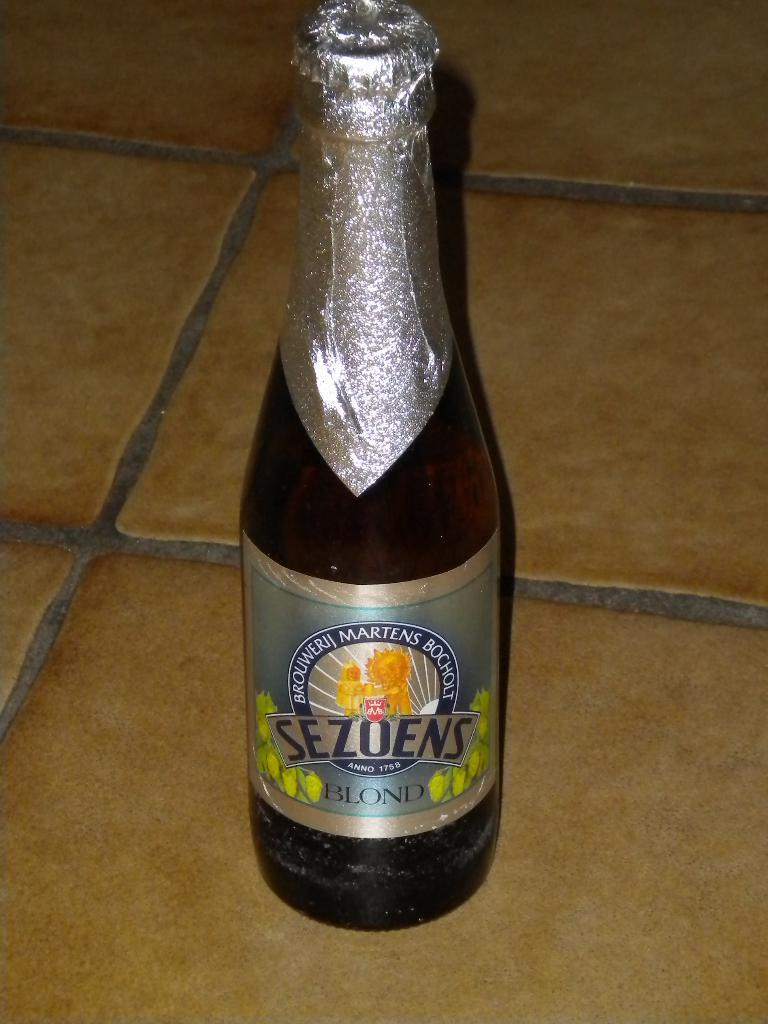What type of beer is bottled here?
Keep it short and to the point. Sezoens. In what year was the brewery established?
Your answer should be very brief. 1758. 